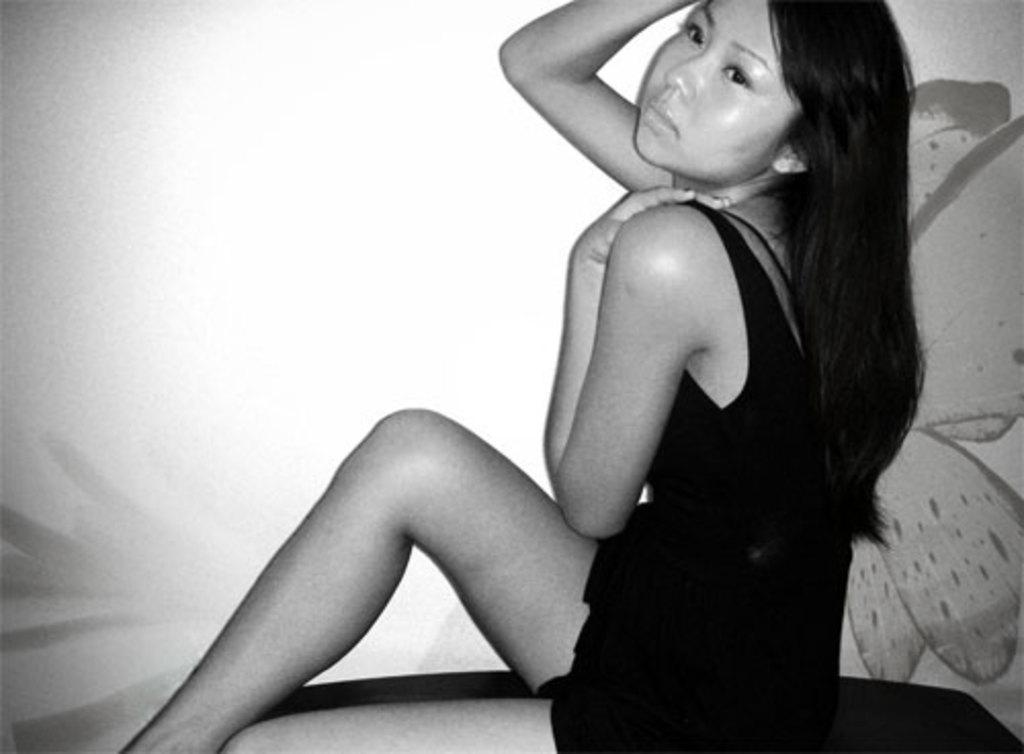Could you give a brief overview of what you see in this image? In this image, in the middle, we can see a woman wearing a black color dress is sitting. On the right side, we can see a painting of a butterfly. 